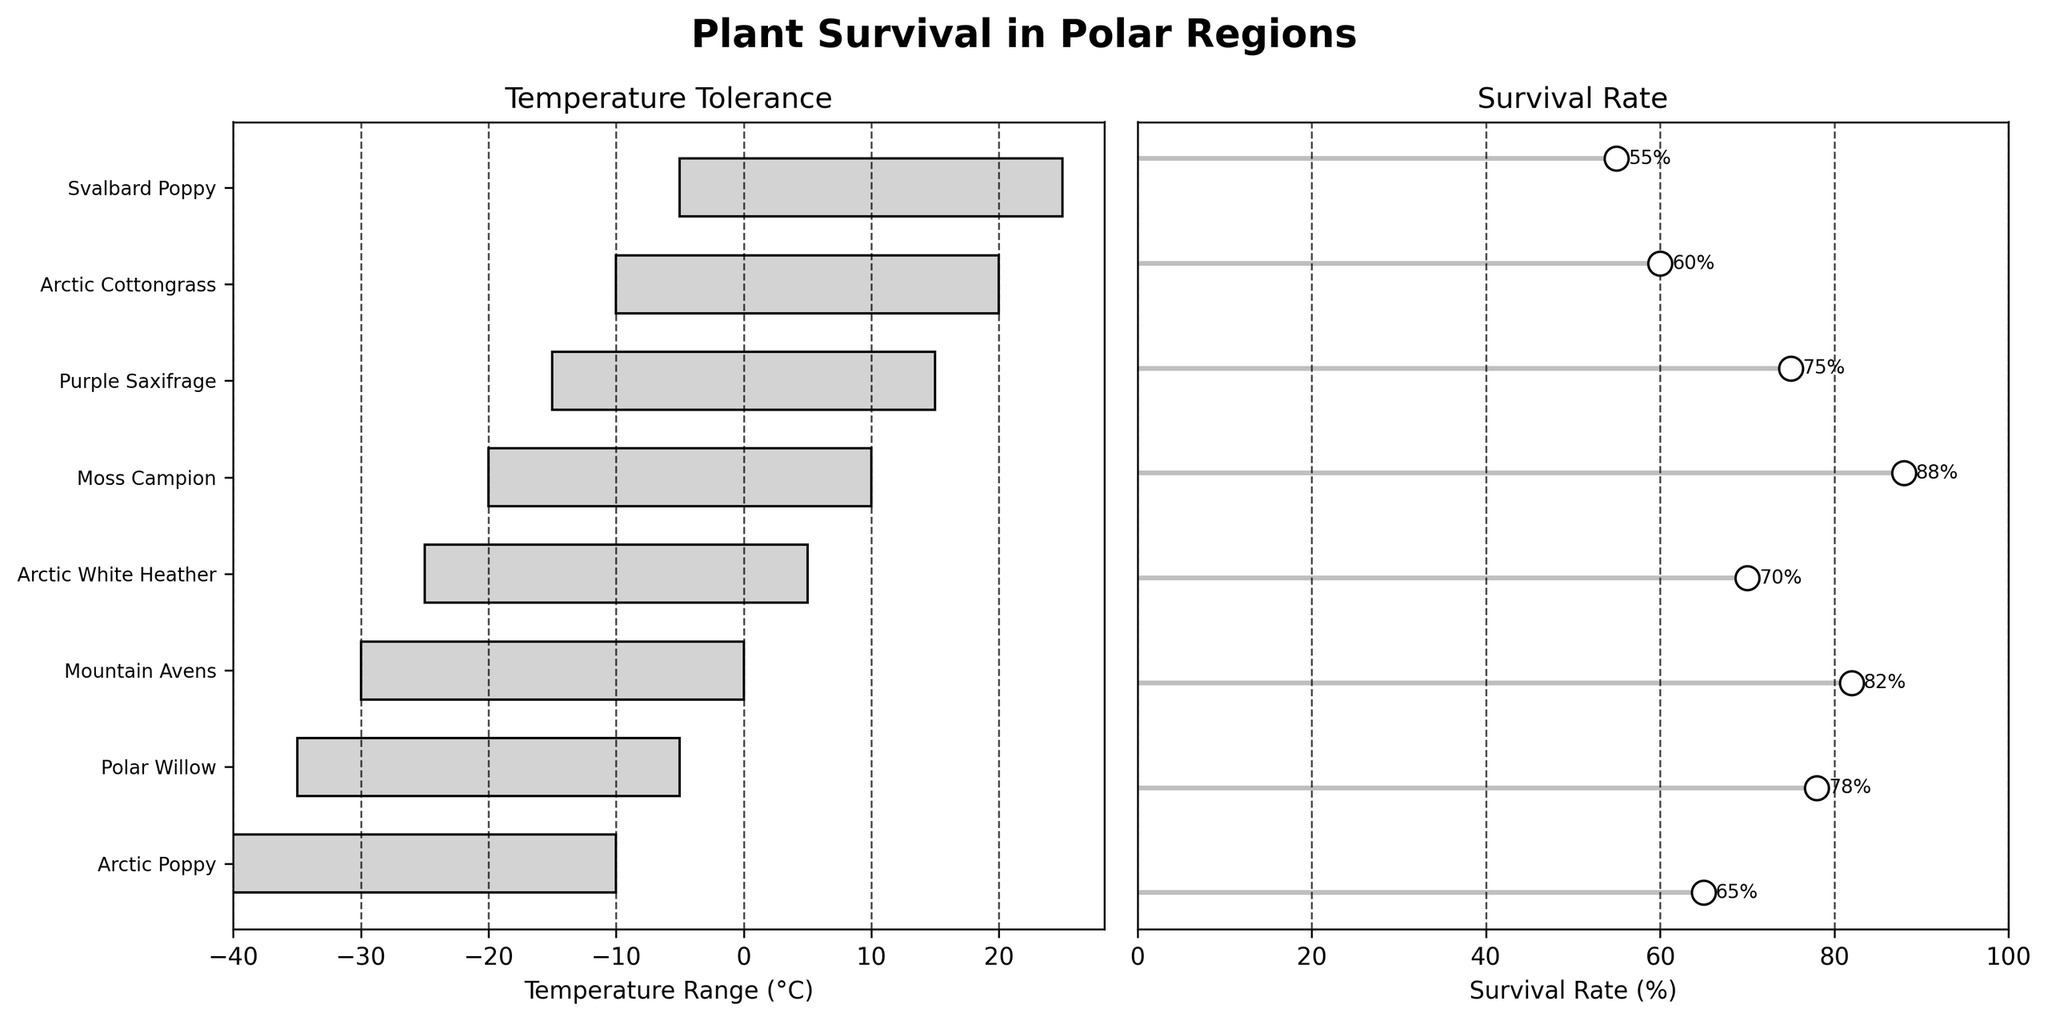How many species are listed in the figure? Count the total number of species labeled on the y-axes. There are eight species listed.
Answer: Eight Which species has the widest temperature range? Compare the lengths of the temperature ranges on the first subplot. The Arctic Cottongrass has the widest temperature range of 30°C (-10 to 20°C).
Answer: Arctic Cottongrass What is the survival rate of Moss Campion? Find the Moss Campion label in the survival rate subplot and read the associated survival rate. Moss Campion has a survival rate of 88%.
Answer: 88% Which species has the highest survival rate, and what is it? Compare the survival rates on the dot plot in the second subplot. Moss Campion has the highest survival rate at 88%.
Answer: Moss Campion, 88% Which species has the narrowest temperature range, and what is the range? Compare the lengths of the bars in the temperature range subplot. Svalbard Poppy has the narrowest range of 30°C (-5 to 25°C).
Answer: Svalbard Poppy, 30°C How does the survival rate of Arctic Poppy compare to Polar Willow? Identify the survival rates of both species and compare them. The Arctic Poppy has a survival rate of 65%, while the Polar Willow has a higher rate of 78%.
Answer: Polar Willow has a higher survival rate than Arctic Poppy What is the average survival rate of all listed species? Sum the survival rates of all species and divide by the number of species. (65 + 78 + 82 + 70 + 88 + 75 + 60 + 55) / 8 = 573 / 8 = 71.625
Answer: 71.625% Which species can tolerate temperatures as low as -35°C? Locate the species whose temperature range includes -35°C in the first subplot. Polar Willow can tolerate temperatures as low as -35°C.
Answer: Polar Willow What is the difference in survival rates between Arctic White Heather and Arctic Cottongrass? Subtract the survival rate of Arctic Cottongrass from that of Arctic White Heather. 70% - 60% = 10%
Answer: 10% How is the survival rate of Svalbard Poppy visually represented in the figure? Describe the representation in the survival rate subplot. There is a white dot at 55% on the y-axis with a corresponding horizontal line extending to the dot and an annotation showing '55%'.
Answer: white dot at 55%, horizontal line, 55% annotation 